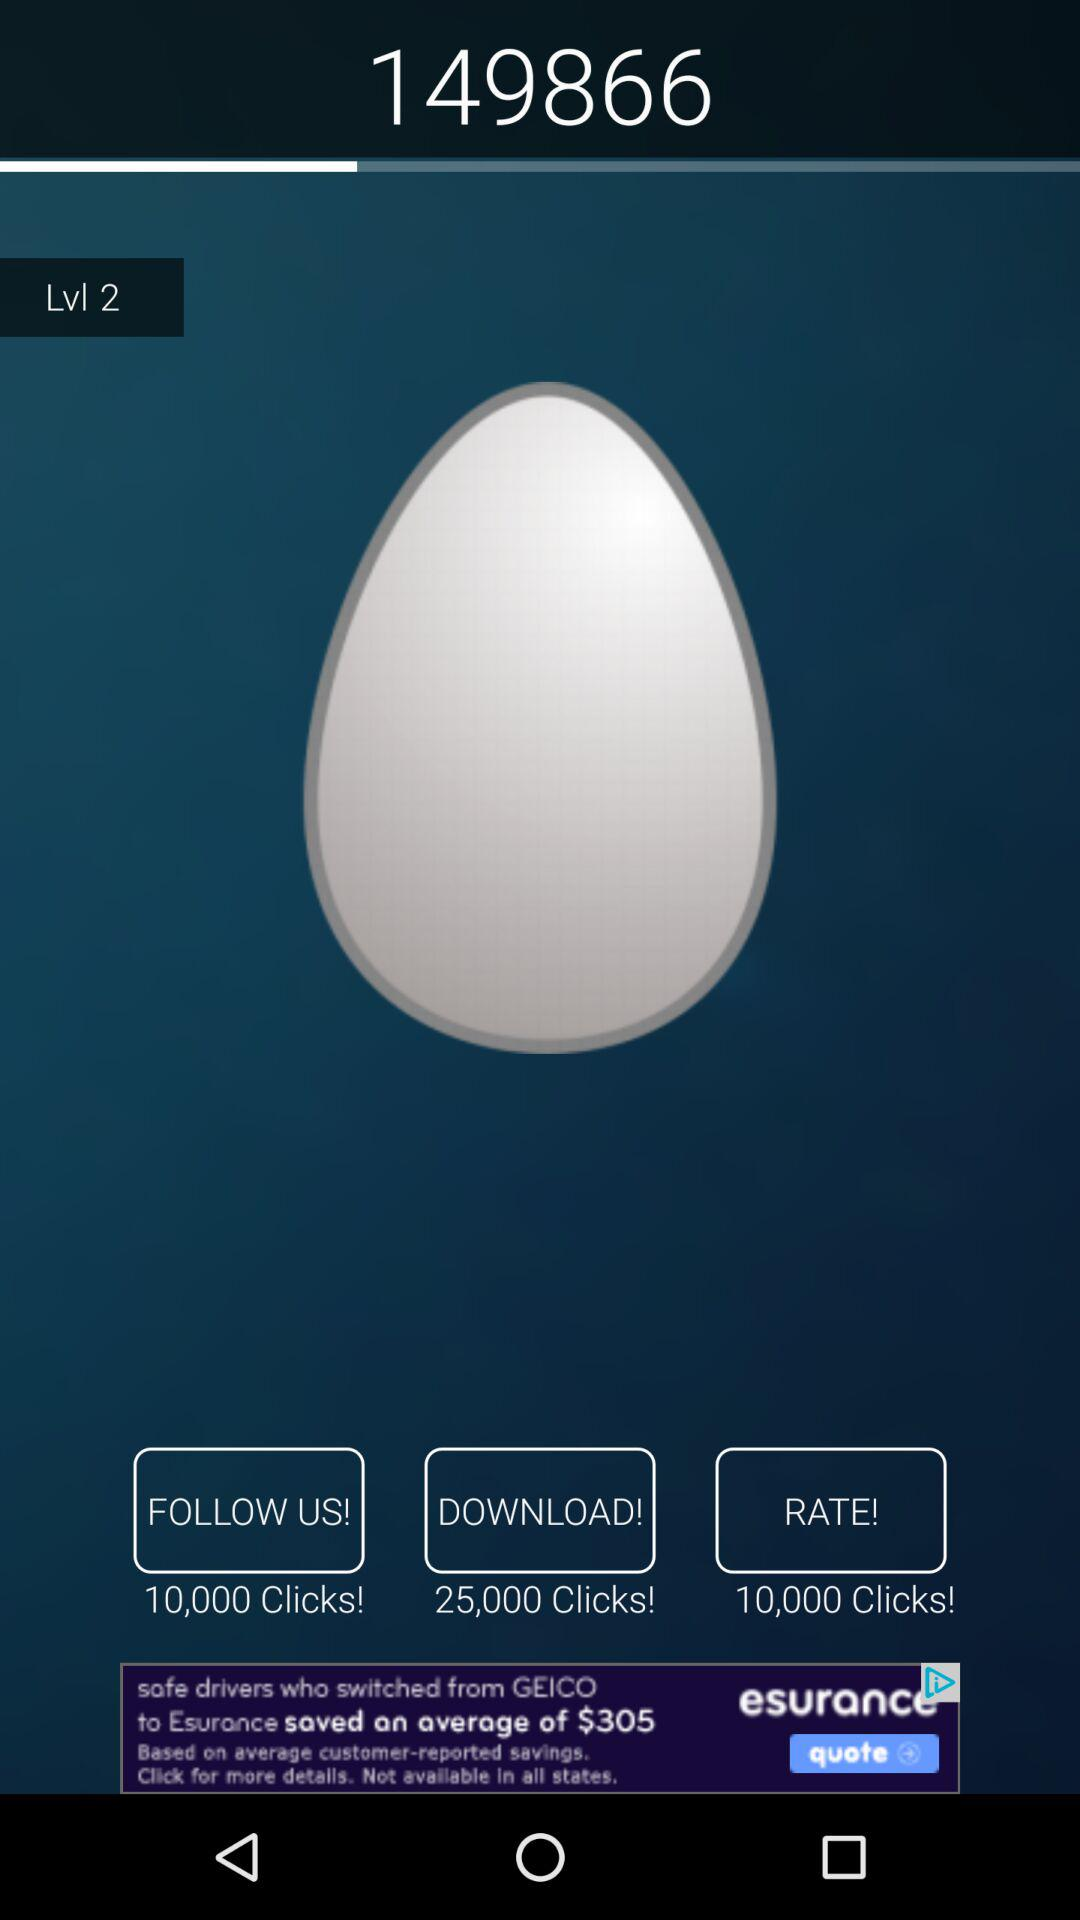How many clicks are there on rate? There are 10,000 clicks. 